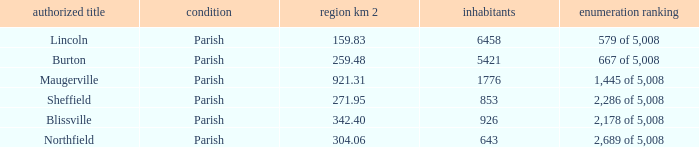What are the official name(s) of places with an area of 304.06 km2? Northfield. 